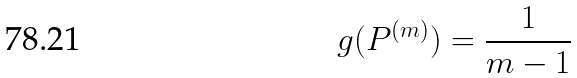Convert formula to latex. <formula><loc_0><loc_0><loc_500><loc_500>g ( P ^ { ( m ) } ) = \frac { 1 } { m - 1 }</formula> 